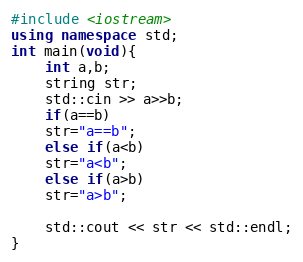Convert code to text. <code><loc_0><loc_0><loc_500><loc_500><_C++_>#include <iostream>
using namespace std;
int main(void){
    int a,b;
    string str;
    std::cin >> a>>b;
    if(a==b)
    str="a==b";
    else if(a<b)
    str="a<b";
    else if(a>b)
    str="a>b";
    
    std::cout << str << std::endl;
}
</code> 